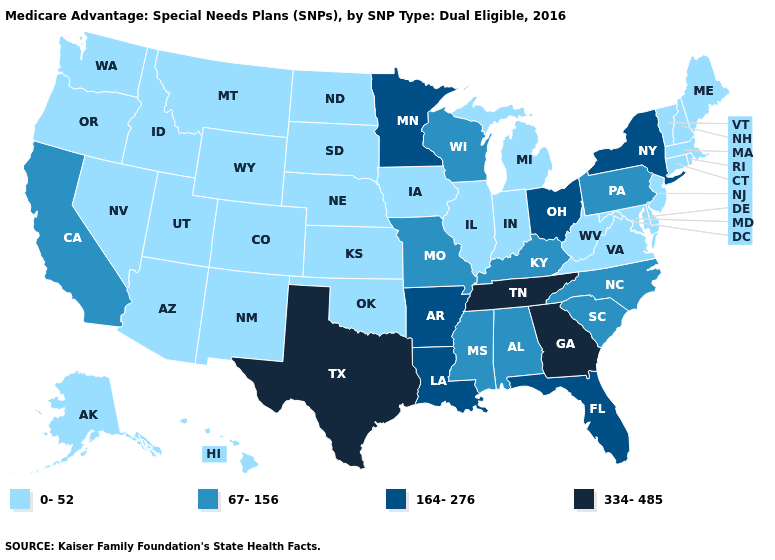Name the states that have a value in the range 334-485?
Answer briefly. Georgia, Tennessee, Texas. What is the value of Nebraska?
Write a very short answer. 0-52. Name the states that have a value in the range 0-52?
Keep it brief. Alaska, Arizona, Colorado, Connecticut, Delaware, Hawaii, Iowa, Idaho, Illinois, Indiana, Kansas, Massachusetts, Maryland, Maine, Michigan, Montana, North Dakota, Nebraska, New Hampshire, New Jersey, New Mexico, Nevada, Oklahoma, Oregon, Rhode Island, South Dakota, Utah, Virginia, Vermont, Washington, West Virginia, Wyoming. Does South Dakota have the highest value in the MidWest?
Write a very short answer. No. Name the states that have a value in the range 164-276?
Quick response, please. Arkansas, Florida, Louisiana, Minnesota, New York, Ohio. Does Washington have a lower value than Texas?
Be succinct. Yes. Does New Hampshire have the lowest value in the Northeast?
Concise answer only. Yes. Which states hav the highest value in the South?
Keep it brief. Georgia, Tennessee, Texas. Which states have the highest value in the USA?
Keep it brief. Georgia, Tennessee, Texas. Among the states that border Indiana , does Ohio have the highest value?
Short answer required. Yes. What is the value of Vermont?
Answer briefly. 0-52. Does New Mexico have the same value as Connecticut?
Quick response, please. Yes. Which states have the lowest value in the USA?
Be succinct. Alaska, Arizona, Colorado, Connecticut, Delaware, Hawaii, Iowa, Idaho, Illinois, Indiana, Kansas, Massachusetts, Maryland, Maine, Michigan, Montana, North Dakota, Nebraska, New Hampshire, New Jersey, New Mexico, Nevada, Oklahoma, Oregon, Rhode Island, South Dakota, Utah, Virginia, Vermont, Washington, West Virginia, Wyoming. 